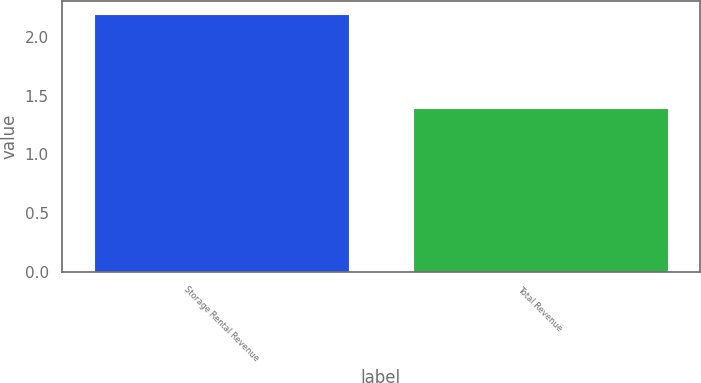Convert chart. <chart><loc_0><loc_0><loc_500><loc_500><bar_chart><fcel>Storage Rental Revenue<fcel>Total Revenue<nl><fcel>2.2<fcel>1.4<nl></chart> 